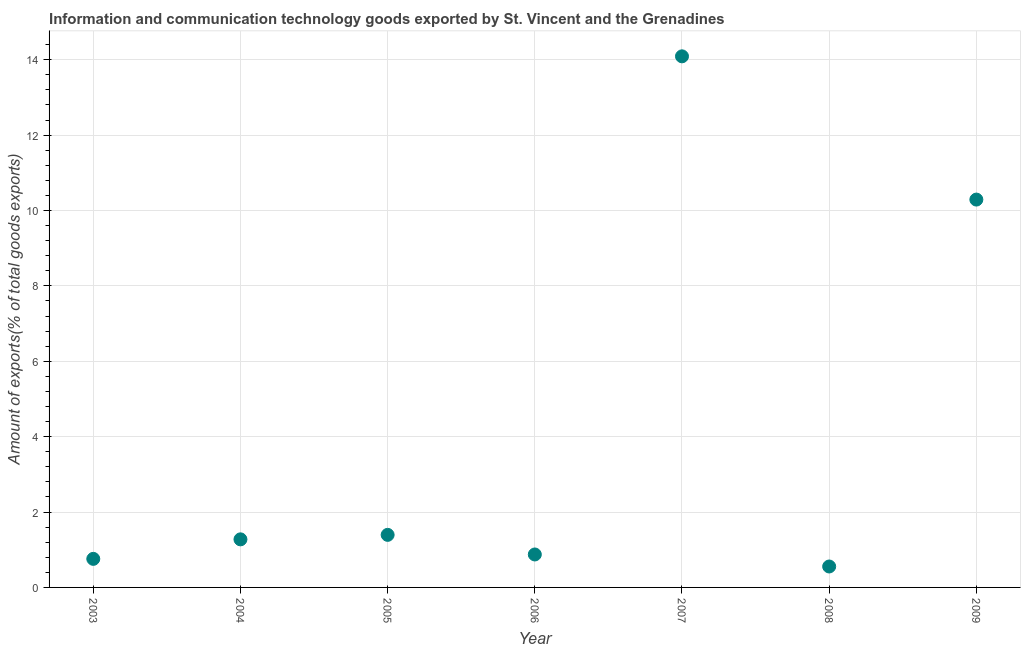What is the amount of ict goods exports in 2006?
Offer a very short reply. 0.87. Across all years, what is the maximum amount of ict goods exports?
Offer a very short reply. 14.09. Across all years, what is the minimum amount of ict goods exports?
Your response must be concise. 0.56. In which year was the amount of ict goods exports maximum?
Your answer should be very brief. 2007. In which year was the amount of ict goods exports minimum?
Make the answer very short. 2008. What is the sum of the amount of ict goods exports?
Offer a terse response. 29.24. What is the difference between the amount of ict goods exports in 2004 and 2009?
Offer a very short reply. -9.01. What is the average amount of ict goods exports per year?
Your answer should be very brief. 4.18. What is the median amount of ict goods exports?
Offer a terse response. 1.28. What is the ratio of the amount of ict goods exports in 2004 to that in 2009?
Your response must be concise. 0.12. Is the amount of ict goods exports in 2008 less than that in 2009?
Your answer should be compact. Yes. What is the difference between the highest and the second highest amount of ict goods exports?
Keep it short and to the point. 3.8. What is the difference between the highest and the lowest amount of ict goods exports?
Give a very brief answer. 13.53. Does the amount of ict goods exports monotonically increase over the years?
Provide a succinct answer. No. How many years are there in the graph?
Keep it short and to the point. 7. What is the title of the graph?
Offer a terse response. Information and communication technology goods exported by St. Vincent and the Grenadines. What is the label or title of the Y-axis?
Offer a terse response. Amount of exports(% of total goods exports). What is the Amount of exports(% of total goods exports) in 2003?
Provide a short and direct response. 0.76. What is the Amount of exports(% of total goods exports) in 2004?
Keep it short and to the point. 1.28. What is the Amount of exports(% of total goods exports) in 2005?
Provide a succinct answer. 1.39. What is the Amount of exports(% of total goods exports) in 2006?
Provide a short and direct response. 0.87. What is the Amount of exports(% of total goods exports) in 2007?
Keep it short and to the point. 14.09. What is the Amount of exports(% of total goods exports) in 2008?
Make the answer very short. 0.56. What is the Amount of exports(% of total goods exports) in 2009?
Your answer should be compact. 10.29. What is the difference between the Amount of exports(% of total goods exports) in 2003 and 2004?
Your answer should be very brief. -0.52. What is the difference between the Amount of exports(% of total goods exports) in 2003 and 2005?
Offer a terse response. -0.64. What is the difference between the Amount of exports(% of total goods exports) in 2003 and 2006?
Ensure brevity in your answer.  -0.12. What is the difference between the Amount of exports(% of total goods exports) in 2003 and 2007?
Keep it short and to the point. -13.33. What is the difference between the Amount of exports(% of total goods exports) in 2003 and 2008?
Your response must be concise. 0.2. What is the difference between the Amount of exports(% of total goods exports) in 2003 and 2009?
Give a very brief answer. -9.53. What is the difference between the Amount of exports(% of total goods exports) in 2004 and 2005?
Your response must be concise. -0.12. What is the difference between the Amount of exports(% of total goods exports) in 2004 and 2006?
Ensure brevity in your answer.  0.4. What is the difference between the Amount of exports(% of total goods exports) in 2004 and 2007?
Your response must be concise. -12.81. What is the difference between the Amount of exports(% of total goods exports) in 2004 and 2008?
Provide a short and direct response. 0.72. What is the difference between the Amount of exports(% of total goods exports) in 2004 and 2009?
Offer a very short reply. -9.01. What is the difference between the Amount of exports(% of total goods exports) in 2005 and 2006?
Offer a very short reply. 0.52. What is the difference between the Amount of exports(% of total goods exports) in 2005 and 2007?
Offer a very short reply. -12.69. What is the difference between the Amount of exports(% of total goods exports) in 2005 and 2008?
Your response must be concise. 0.84. What is the difference between the Amount of exports(% of total goods exports) in 2005 and 2009?
Keep it short and to the point. -8.89. What is the difference between the Amount of exports(% of total goods exports) in 2006 and 2007?
Ensure brevity in your answer.  -13.21. What is the difference between the Amount of exports(% of total goods exports) in 2006 and 2008?
Your response must be concise. 0.32. What is the difference between the Amount of exports(% of total goods exports) in 2006 and 2009?
Offer a terse response. -9.41. What is the difference between the Amount of exports(% of total goods exports) in 2007 and 2008?
Offer a terse response. 13.53. What is the difference between the Amount of exports(% of total goods exports) in 2007 and 2009?
Provide a short and direct response. 3.8. What is the difference between the Amount of exports(% of total goods exports) in 2008 and 2009?
Your answer should be very brief. -9.73. What is the ratio of the Amount of exports(% of total goods exports) in 2003 to that in 2004?
Keep it short and to the point. 0.59. What is the ratio of the Amount of exports(% of total goods exports) in 2003 to that in 2005?
Your response must be concise. 0.54. What is the ratio of the Amount of exports(% of total goods exports) in 2003 to that in 2006?
Your answer should be very brief. 0.87. What is the ratio of the Amount of exports(% of total goods exports) in 2003 to that in 2007?
Provide a short and direct response. 0.05. What is the ratio of the Amount of exports(% of total goods exports) in 2003 to that in 2008?
Provide a succinct answer. 1.36. What is the ratio of the Amount of exports(% of total goods exports) in 2003 to that in 2009?
Provide a short and direct response. 0.07. What is the ratio of the Amount of exports(% of total goods exports) in 2004 to that in 2005?
Make the answer very short. 0.92. What is the ratio of the Amount of exports(% of total goods exports) in 2004 to that in 2006?
Provide a short and direct response. 1.46. What is the ratio of the Amount of exports(% of total goods exports) in 2004 to that in 2007?
Provide a succinct answer. 0.09. What is the ratio of the Amount of exports(% of total goods exports) in 2004 to that in 2008?
Make the answer very short. 2.3. What is the ratio of the Amount of exports(% of total goods exports) in 2004 to that in 2009?
Your response must be concise. 0.12. What is the ratio of the Amount of exports(% of total goods exports) in 2005 to that in 2006?
Provide a succinct answer. 1.59. What is the ratio of the Amount of exports(% of total goods exports) in 2005 to that in 2007?
Offer a very short reply. 0.1. What is the ratio of the Amount of exports(% of total goods exports) in 2005 to that in 2008?
Offer a terse response. 2.51. What is the ratio of the Amount of exports(% of total goods exports) in 2005 to that in 2009?
Your response must be concise. 0.14. What is the ratio of the Amount of exports(% of total goods exports) in 2006 to that in 2007?
Your answer should be compact. 0.06. What is the ratio of the Amount of exports(% of total goods exports) in 2006 to that in 2008?
Offer a very short reply. 1.57. What is the ratio of the Amount of exports(% of total goods exports) in 2006 to that in 2009?
Offer a terse response. 0.09. What is the ratio of the Amount of exports(% of total goods exports) in 2007 to that in 2008?
Your response must be concise. 25.37. What is the ratio of the Amount of exports(% of total goods exports) in 2007 to that in 2009?
Your response must be concise. 1.37. What is the ratio of the Amount of exports(% of total goods exports) in 2008 to that in 2009?
Your answer should be compact. 0.05. 